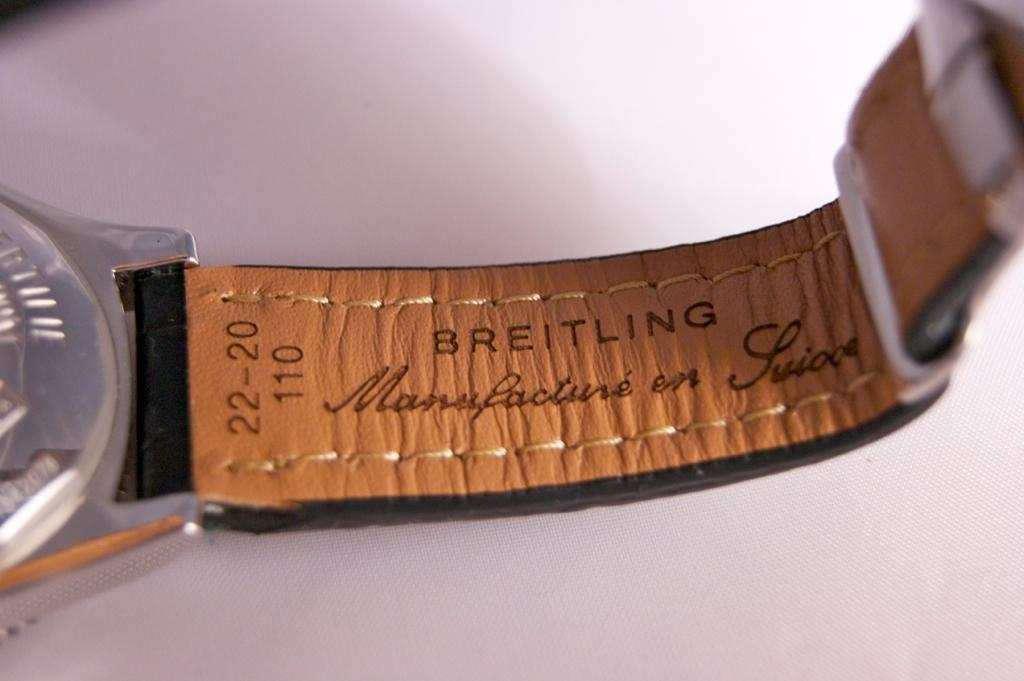<image>
Share a concise interpretation of the image provided. The inside of a watch band says Breitling on it. 